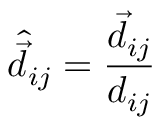<formula> <loc_0><loc_0><loc_500><loc_500>\hat { \vec { d } } _ { i j } = \frac { \vec { d } _ { i j } } { d _ { i j } }</formula> 